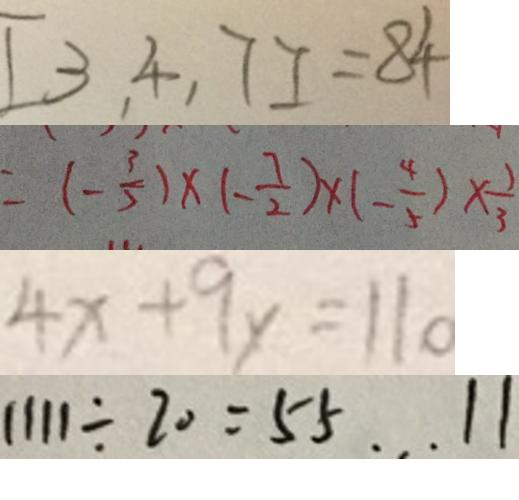<formula> <loc_0><loc_0><loc_500><loc_500>[ 3 , 4 , 7 ] = 8 4 
 = ( - \frac { 3 } { 5 } ) \times ( - \frac { 7 } { 2 } ) \times ( - \frac { 4 } { 5 } ) \times \frac { 1 } { 3 } 
 4 x + 9 y = 1 1 0 
 1 1 1 1 \div 2 0 = 5 5 \cdots 1 1</formula> 